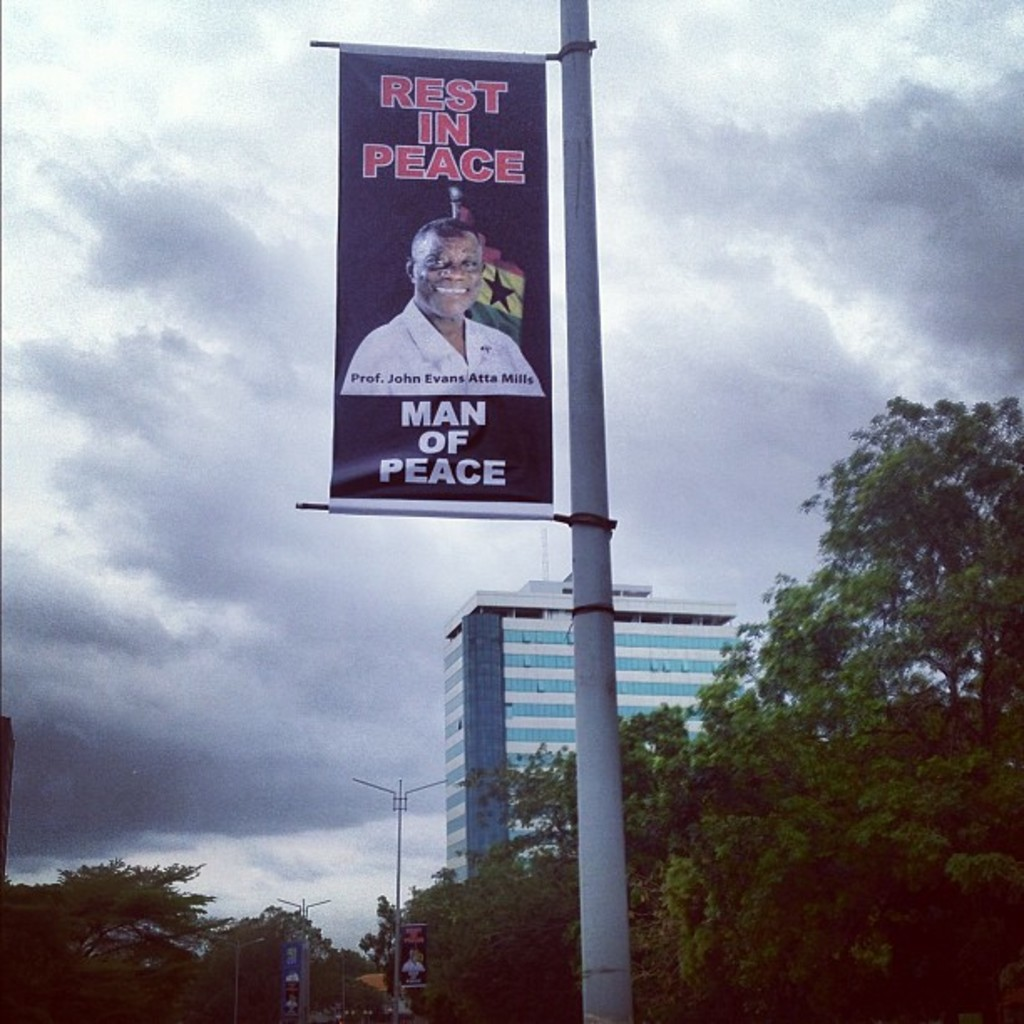Provide a one-sentence caption for the provided image. The image displays a memorial banner of Professor John Evans Atta Mills, celebrating his legacy as a 'Man of Peace' against the backdrop of an overcast sky, likely signifying a period of mourning. 